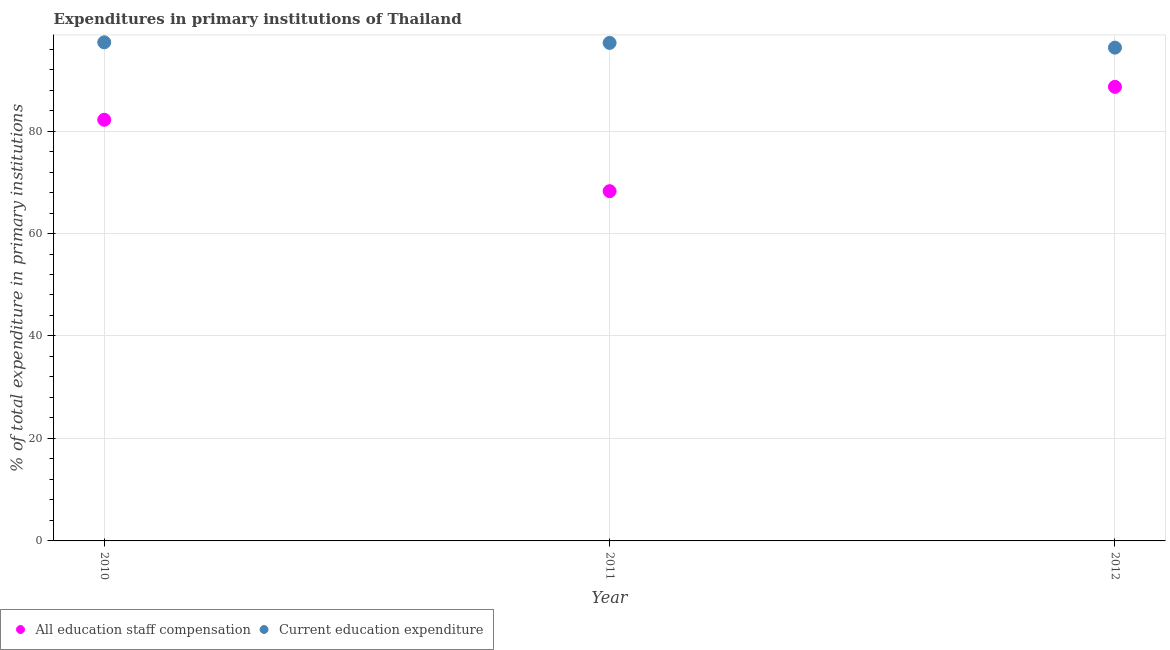What is the expenditure in education in 2012?
Offer a very short reply. 96.28. Across all years, what is the maximum expenditure in staff compensation?
Ensure brevity in your answer.  88.63. Across all years, what is the minimum expenditure in staff compensation?
Your answer should be compact. 68.26. In which year was the expenditure in staff compensation maximum?
Make the answer very short. 2012. In which year was the expenditure in staff compensation minimum?
Make the answer very short. 2011. What is the total expenditure in staff compensation in the graph?
Make the answer very short. 239.09. What is the difference between the expenditure in staff compensation in 2010 and that in 2011?
Your response must be concise. 13.93. What is the difference between the expenditure in staff compensation in 2011 and the expenditure in education in 2010?
Your response must be concise. -29.05. What is the average expenditure in staff compensation per year?
Offer a very short reply. 79.7. In the year 2010, what is the difference between the expenditure in education and expenditure in staff compensation?
Give a very brief answer. 15.12. What is the ratio of the expenditure in staff compensation in 2010 to that in 2011?
Offer a very short reply. 1.2. Is the expenditure in staff compensation in 2010 less than that in 2012?
Your response must be concise. Yes. Is the difference between the expenditure in staff compensation in 2010 and 2012 greater than the difference between the expenditure in education in 2010 and 2012?
Provide a short and direct response. No. What is the difference between the highest and the second highest expenditure in staff compensation?
Ensure brevity in your answer.  6.43. What is the difference between the highest and the lowest expenditure in staff compensation?
Keep it short and to the point. 20.36. In how many years, is the expenditure in staff compensation greater than the average expenditure in staff compensation taken over all years?
Offer a terse response. 2. Is the expenditure in education strictly less than the expenditure in staff compensation over the years?
Your answer should be very brief. No. How many dotlines are there?
Provide a short and direct response. 2. How many years are there in the graph?
Your response must be concise. 3. Does the graph contain any zero values?
Make the answer very short. No. How many legend labels are there?
Offer a terse response. 2. How are the legend labels stacked?
Your answer should be very brief. Horizontal. What is the title of the graph?
Your answer should be compact. Expenditures in primary institutions of Thailand. What is the label or title of the Y-axis?
Offer a terse response. % of total expenditure in primary institutions. What is the % of total expenditure in primary institutions in All education staff compensation in 2010?
Offer a very short reply. 82.2. What is the % of total expenditure in primary institutions of Current education expenditure in 2010?
Keep it short and to the point. 97.32. What is the % of total expenditure in primary institutions of All education staff compensation in 2011?
Your answer should be compact. 68.26. What is the % of total expenditure in primary institutions in Current education expenditure in 2011?
Offer a very short reply. 97.2. What is the % of total expenditure in primary institutions of All education staff compensation in 2012?
Provide a short and direct response. 88.63. What is the % of total expenditure in primary institutions of Current education expenditure in 2012?
Your answer should be compact. 96.28. Across all years, what is the maximum % of total expenditure in primary institutions in All education staff compensation?
Your answer should be compact. 88.63. Across all years, what is the maximum % of total expenditure in primary institutions in Current education expenditure?
Make the answer very short. 97.32. Across all years, what is the minimum % of total expenditure in primary institutions in All education staff compensation?
Give a very brief answer. 68.26. Across all years, what is the minimum % of total expenditure in primary institutions in Current education expenditure?
Give a very brief answer. 96.28. What is the total % of total expenditure in primary institutions of All education staff compensation in the graph?
Offer a very short reply. 239.09. What is the total % of total expenditure in primary institutions of Current education expenditure in the graph?
Offer a very short reply. 290.79. What is the difference between the % of total expenditure in primary institutions in All education staff compensation in 2010 and that in 2011?
Make the answer very short. 13.93. What is the difference between the % of total expenditure in primary institutions of Current education expenditure in 2010 and that in 2011?
Your answer should be very brief. 0.11. What is the difference between the % of total expenditure in primary institutions of All education staff compensation in 2010 and that in 2012?
Make the answer very short. -6.43. What is the difference between the % of total expenditure in primary institutions of Current education expenditure in 2010 and that in 2012?
Your answer should be very brief. 1.04. What is the difference between the % of total expenditure in primary institutions of All education staff compensation in 2011 and that in 2012?
Ensure brevity in your answer.  -20.36. What is the difference between the % of total expenditure in primary institutions in Current education expenditure in 2011 and that in 2012?
Your response must be concise. 0.93. What is the difference between the % of total expenditure in primary institutions of All education staff compensation in 2010 and the % of total expenditure in primary institutions of Current education expenditure in 2011?
Provide a succinct answer. -15. What is the difference between the % of total expenditure in primary institutions of All education staff compensation in 2010 and the % of total expenditure in primary institutions of Current education expenditure in 2012?
Offer a very short reply. -14.08. What is the difference between the % of total expenditure in primary institutions in All education staff compensation in 2011 and the % of total expenditure in primary institutions in Current education expenditure in 2012?
Make the answer very short. -28.01. What is the average % of total expenditure in primary institutions in All education staff compensation per year?
Your answer should be compact. 79.7. What is the average % of total expenditure in primary institutions in Current education expenditure per year?
Give a very brief answer. 96.93. In the year 2010, what is the difference between the % of total expenditure in primary institutions of All education staff compensation and % of total expenditure in primary institutions of Current education expenditure?
Provide a succinct answer. -15.12. In the year 2011, what is the difference between the % of total expenditure in primary institutions of All education staff compensation and % of total expenditure in primary institutions of Current education expenditure?
Your answer should be compact. -28.94. In the year 2012, what is the difference between the % of total expenditure in primary institutions in All education staff compensation and % of total expenditure in primary institutions in Current education expenditure?
Offer a terse response. -7.65. What is the ratio of the % of total expenditure in primary institutions of All education staff compensation in 2010 to that in 2011?
Your answer should be compact. 1.2. What is the ratio of the % of total expenditure in primary institutions of Current education expenditure in 2010 to that in 2011?
Make the answer very short. 1. What is the ratio of the % of total expenditure in primary institutions in All education staff compensation in 2010 to that in 2012?
Make the answer very short. 0.93. What is the ratio of the % of total expenditure in primary institutions in Current education expenditure in 2010 to that in 2012?
Keep it short and to the point. 1.01. What is the ratio of the % of total expenditure in primary institutions of All education staff compensation in 2011 to that in 2012?
Give a very brief answer. 0.77. What is the ratio of the % of total expenditure in primary institutions in Current education expenditure in 2011 to that in 2012?
Ensure brevity in your answer.  1.01. What is the difference between the highest and the second highest % of total expenditure in primary institutions of All education staff compensation?
Make the answer very short. 6.43. What is the difference between the highest and the second highest % of total expenditure in primary institutions of Current education expenditure?
Provide a short and direct response. 0.11. What is the difference between the highest and the lowest % of total expenditure in primary institutions of All education staff compensation?
Offer a terse response. 20.36. What is the difference between the highest and the lowest % of total expenditure in primary institutions of Current education expenditure?
Your answer should be compact. 1.04. 